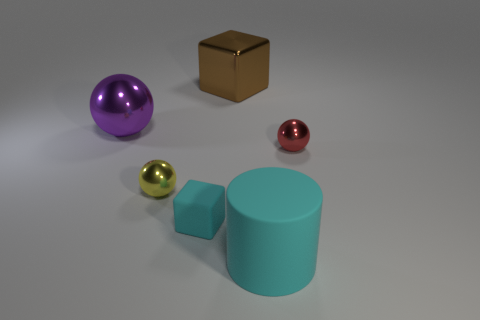Subtract all small yellow spheres. How many spheres are left? 2 Add 4 tiny yellow spheres. How many objects exist? 10 Subtract all cubes. How many objects are left? 4 Subtract all red spheres. How many spheres are left? 2 Add 2 small red objects. How many small red objects are left? 3 Add 4 cyan blocks. How many cyan blocks exist? 5 Subtract 1 cyan cubes. How many objects are left? 5 Subtract all red cylinders. Subtract all purple blocks. How many cylinders are left? 1 Subtract all tiny matte cylinders. Subtract all brown metal cubes. How many objects are left? 5 